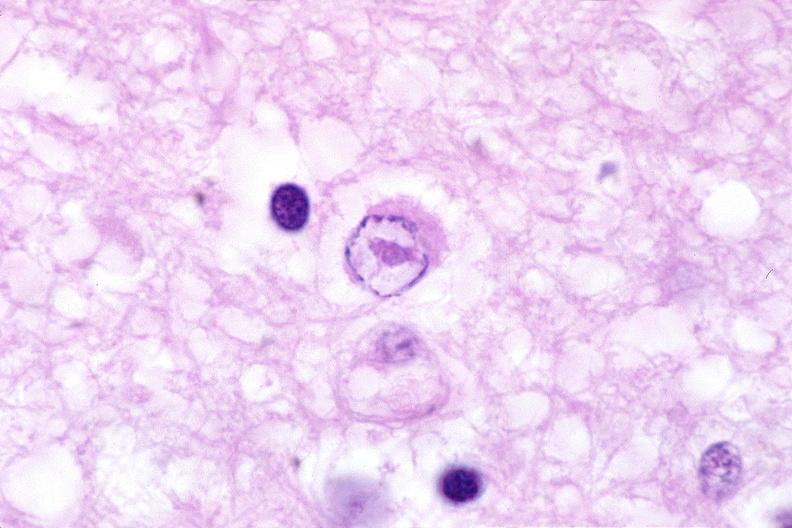what does this image show?
Answer the question using a single word or phrase. Brain 